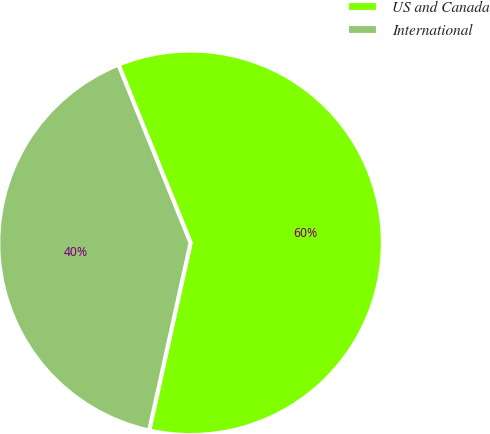Convert chart. <chart><loc_0><loc_0><loc_500><loc_500><pie_chart><fcel>US and Canada<fcel>International<nl><fcel>59.58%<fcel>40.42%<nl></chart> 